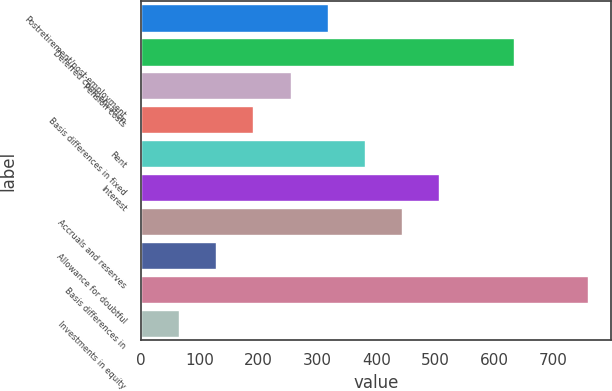Convert chart. <chart><loc_0><loc_0><loc_500><loc_500><bar_chart><fcel>Postretirement/post-employment<fcel>Deferred compensation<fcel>Pension costs<fcel>Basis differences in fixed<fcel>Rent<fcel>Interest<fcel>Accruals and reserves<fcel>Allowance for doubtful<fcel>Basis differences in<fcel>Investments in equity<nl><fcel>317.2<fcel>633.2<fcel>254<fcel>190.8<fcel>380.4<fcel>506.8<fcel>443.6<fcel>127.6<fcel>759.6<fcel>64.4<nl></chart> 